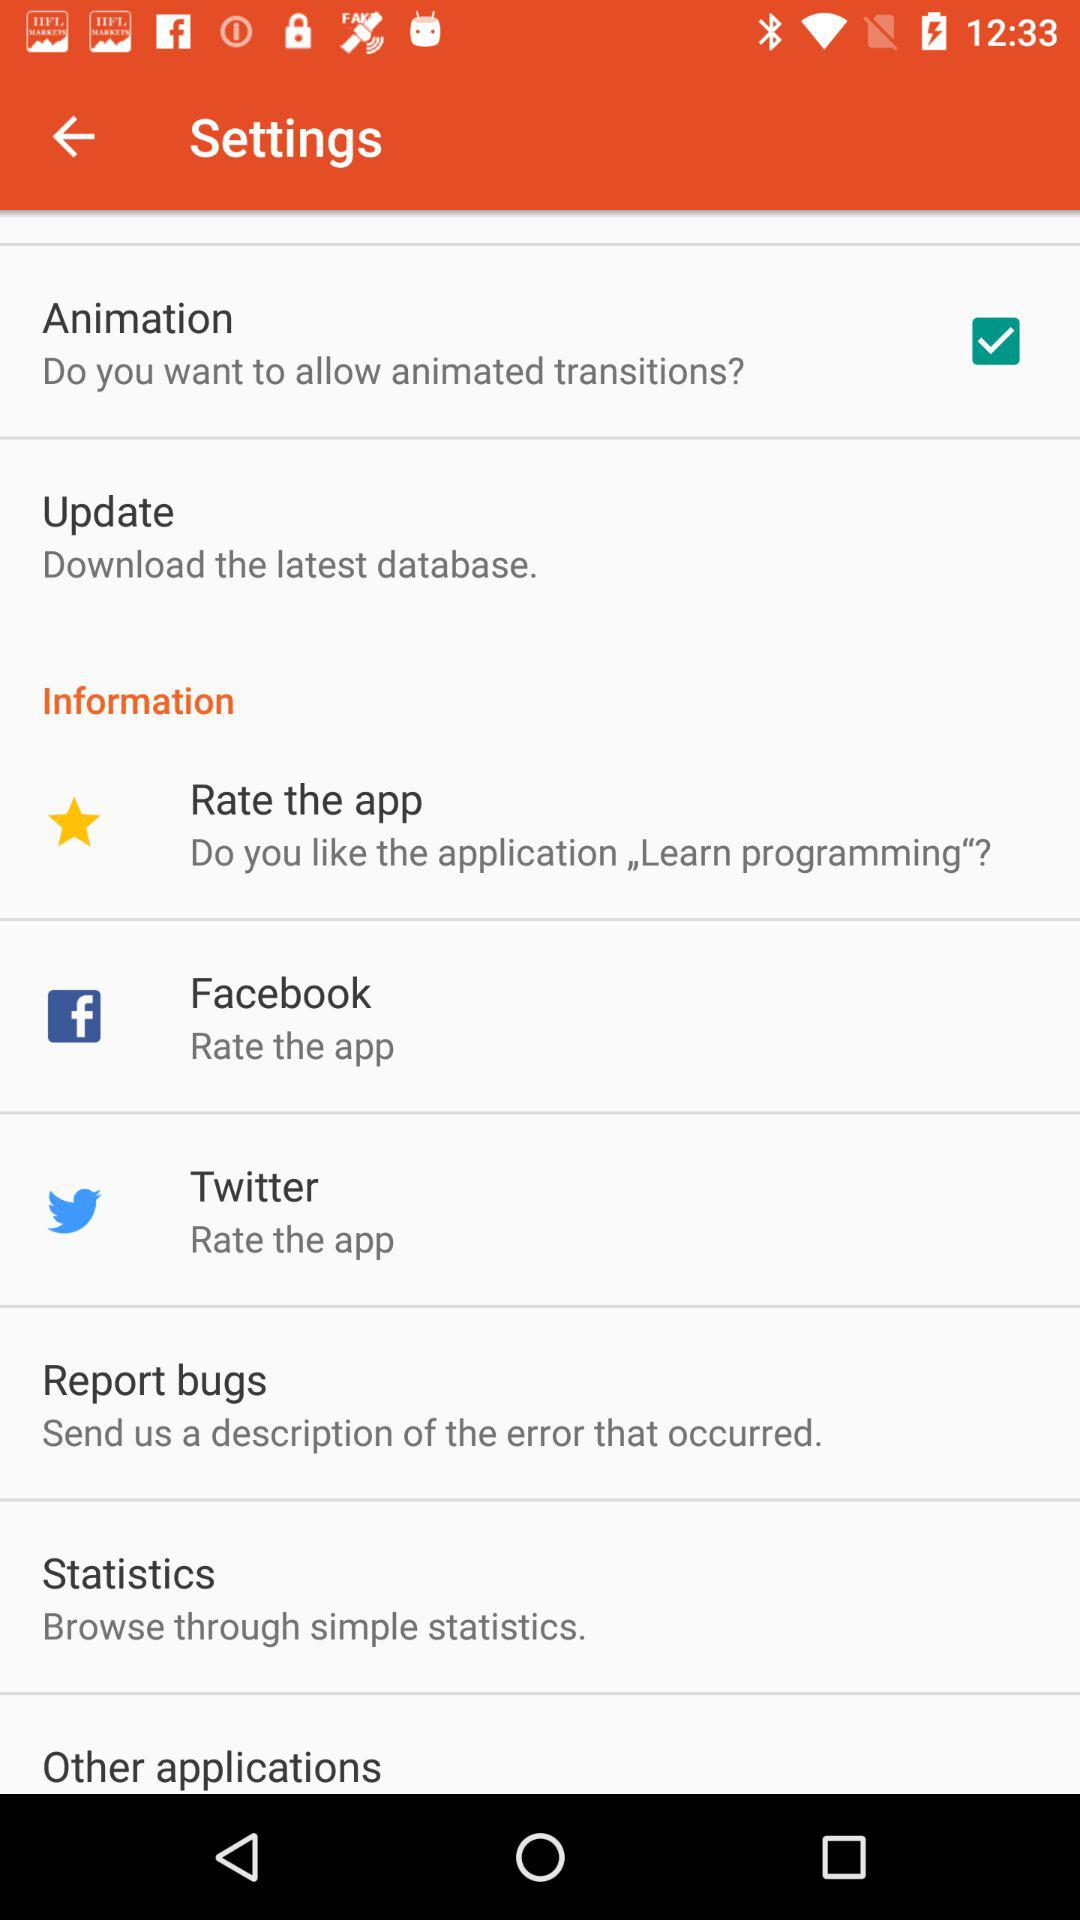What is the status of twitter?
When the provided information is insufficient, respond with <no answer>. <no answer> 